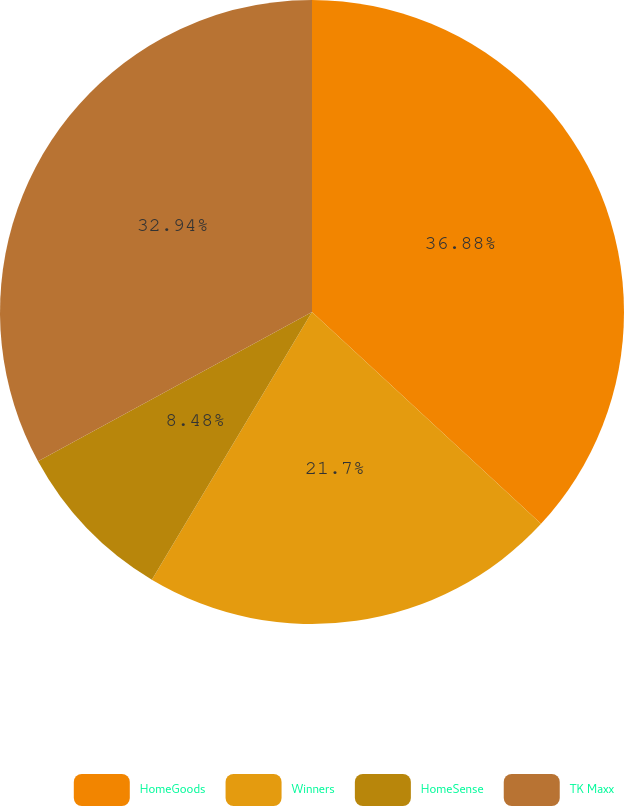Convert chart to OTSL. <chart><loc_0><loc_0><loc_500><loc_500><pie_chart><fcel>HomeGoods<fcel>Winners<fcel>HomeSense<fcel>TK Maxx<nl><fcel>36.88%<fcel>21.7%<fcel>8.48%<fcel>32.94%<nl></chart> 